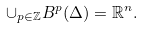Convert formula to latex. <formula><loc_0><loc_0><loc_500><loc_500>\cup _ { p \in \mathbb { Z } } B ^ { p } ( \Delta ) = \mathbb { R } ^ { n } .</formula> 